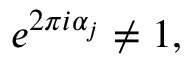<formula> <loc_0><loc_0><loc_500><loc_500>e ^ { 2 \pi i \alpha _ { j } } \neq 1 ,</formula> 